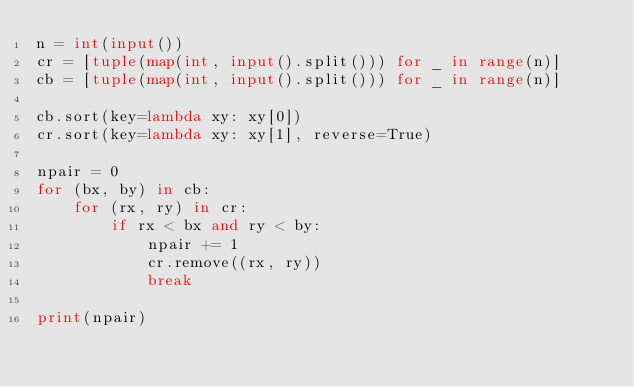<code> <loc_0><loc_0><loc_500><loc_500><_Python_>n = int(input())
cr = [tuple(map(int, input().split())) for _ in range(n)]
cb = [tuple(map(int, input().split())) for _ in range(n)]

cb.sort(key=lambda xy: xy[0])
cr.sort(key=lambda xy: xy[1], reverse=True)

npair = 0
for (bx, by) in cb:
    for (rx, ry) in cr:
        if rx < bx and ry < by:
            npair += 1
            cr.remove((rx, ry))
            break

print(npair)



</code> 